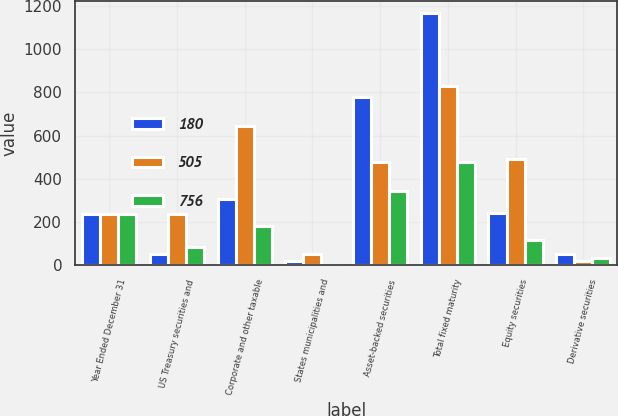Convert chart to OTSL. <chart><loc_0><loc_0><loc_500><loc_500><stacked_bar_chart><ecel><fcel>Year Ended December 31<fcel>US Treasury securities and<fcel>Corporate and other taxable<fcel>States municipalities and<fcel>Asset-backed securities<fcel>Total fixed maturity<fcel>Equity securities<fcel>Derivative securities<nl><fcel>180<fcel>235<fcel>53<fcel>306<fcel>21<fcel>778<fcel>1167<fcel>243<fcel>51<nl><fcel>505<fcel>235<fcel>235<fcel>643<fcel>53<fcel>476<fcel>831<fcel>490<fcel>19<nl><fcel>756<fcel>235<fcel>86<fcel>183<fcel>3<fcel>343<fcel>478<fcel>117<fcel>32<nl></chart> 